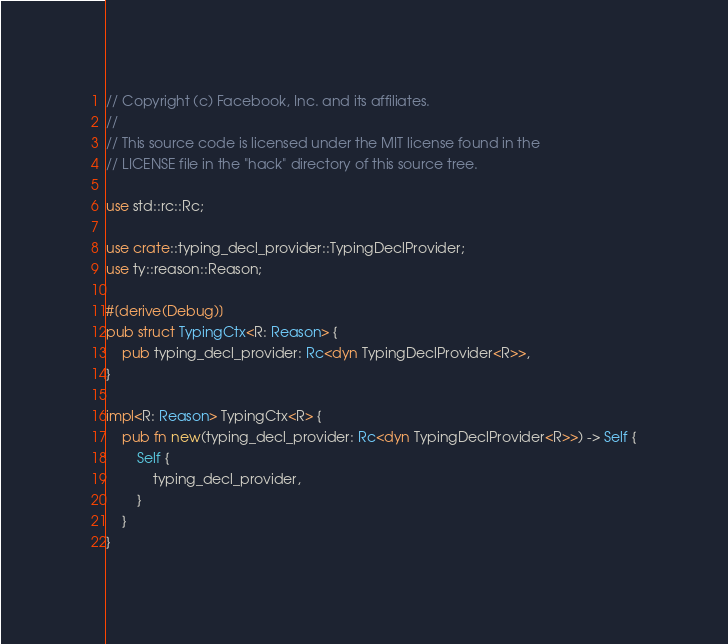Convert code to text. <code><loc_0><loc_0><loc_500><loc_500><_Rust_>// Copyright (c) Facebook, Inc. and its affiliates.
//
// This source code is licensed under the MIT license found in the
// LICENSE file in the "hack" directory of this source tree.

use std::rc::Rc;

use crate::typing_decl_provider::TypingDeclProvider;
use ty::reason::Reason;

#[derive(Debug)]
pub struct TypingCtx<R: Reason> {
    pub typing_decl_provider: Rc<dyn TypingDeclProvider<R>>,
}

impl<R: Reason> TypingCtx<R> {
    pub fn new(typing_decl_provider: Rc<dyn TypingDeclProvider<R>>) -> Self {
        Self {
            typing_decl_provider,
        }
    }
}
</code> 